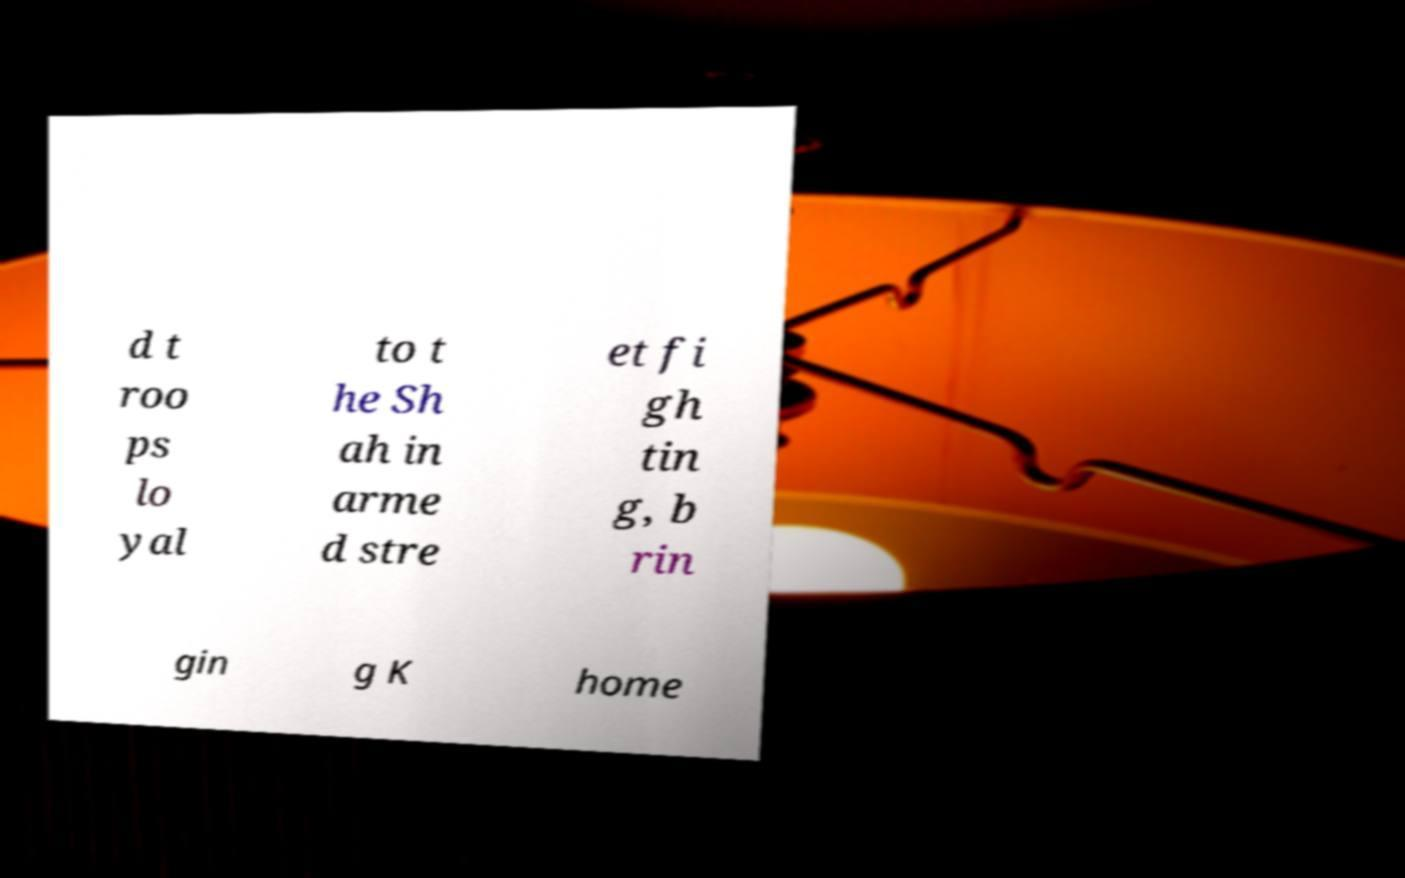What messages or text are displayed in this image? I need them in a readable, typed format. d t roo ps lo yal to t he Sh ah in arme d stre et fi gh tin g, b rin gin g K home 